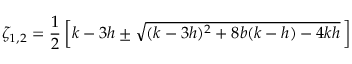<formula> <loc_0><loc_0><loc_500><loc_500>\zeta _ { 1 , 2 } = \frac { 1 } { 2 } \left [ k - 3 h \pm \sqrt { ( k - 3 h ) ^ { 2 } + 8 b ( k - h ) - 4 k h } \, \right ]</formula> 